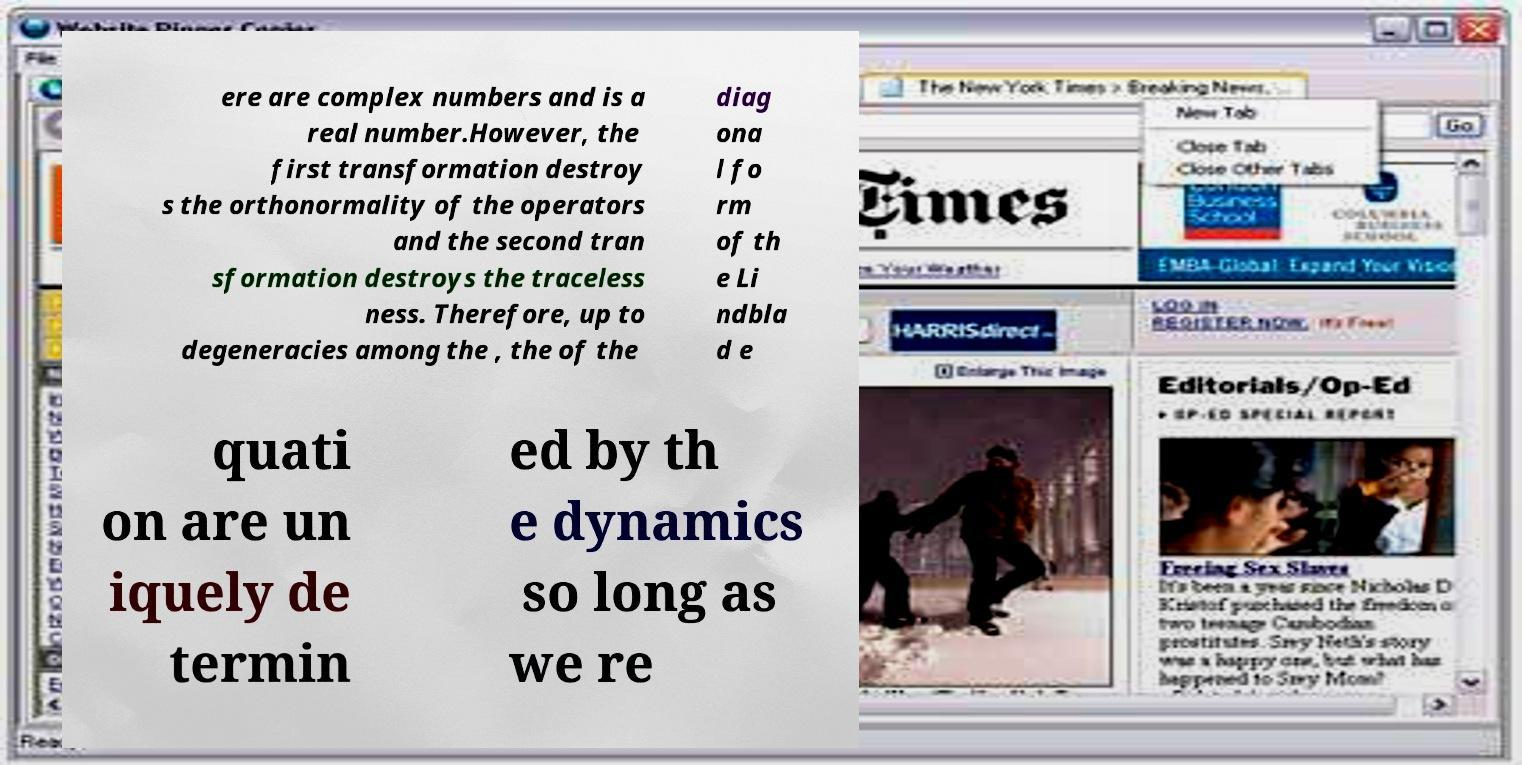What messages or text are displayed in this image? I need them in a readable, typed format. ere are complex numbers and is a real number.However, the first transformation destroy s the orthonormality of the operators and the second tran sformation destroys the traceless ness. Therefore, up to degeneracies among the , the of the diag ona l fo rm of th e Li ndbla d e quati on are un iquely de termin ed by th e dynamics so long as we re 